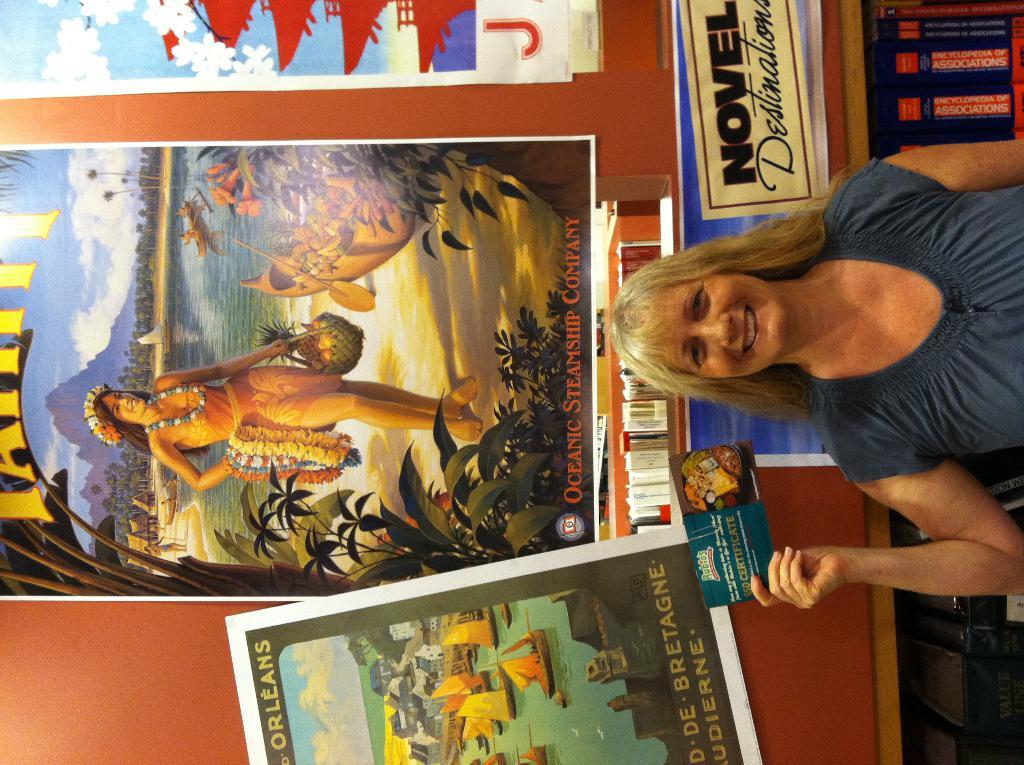<image>
Share a concise interpretation of the image provided. A smiling woman won a $50 certificate to Rubios. 